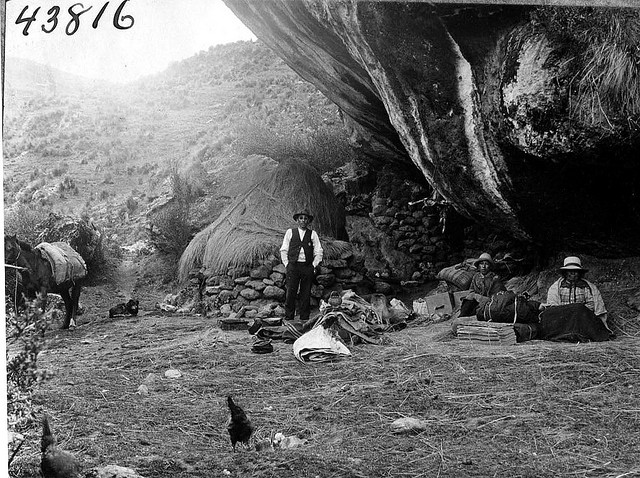Identify the text displayed in this image. 43816 